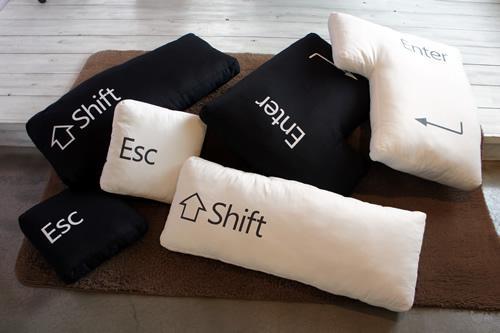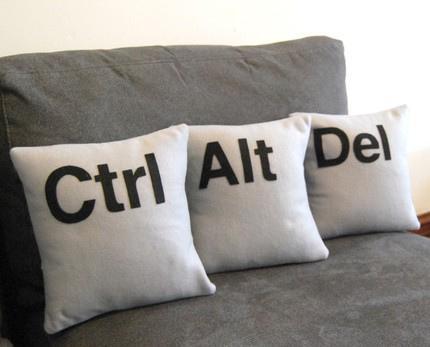The first image is the image on the left, the second image is the image on the right. Evaluate the accuracy of this statement regarding the images: "Every throw pillow pictured is square and whitish with at least one black letter on it, and each image contains exactly three throw pillows.". Is it true? Answer yes or no. No. The first image is the image on the left, the second image is the image on the right. Assess this claim about the two images: "All of the pillows are computer related.". Correct or not? Answer yes or no. Yes. 